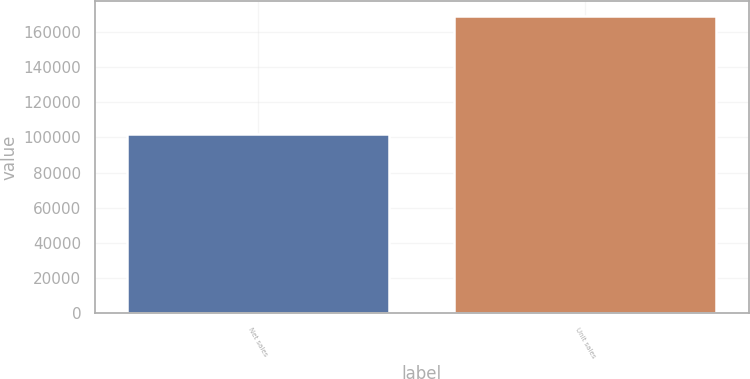Convert chart to OTSL. <chart><loc_0><loc_0><loc_500><loc_500><bar_chart><fcel>Net sales<fcel>Unit sales<nl><fcel>101991<fcel>169219<nl></chart> 